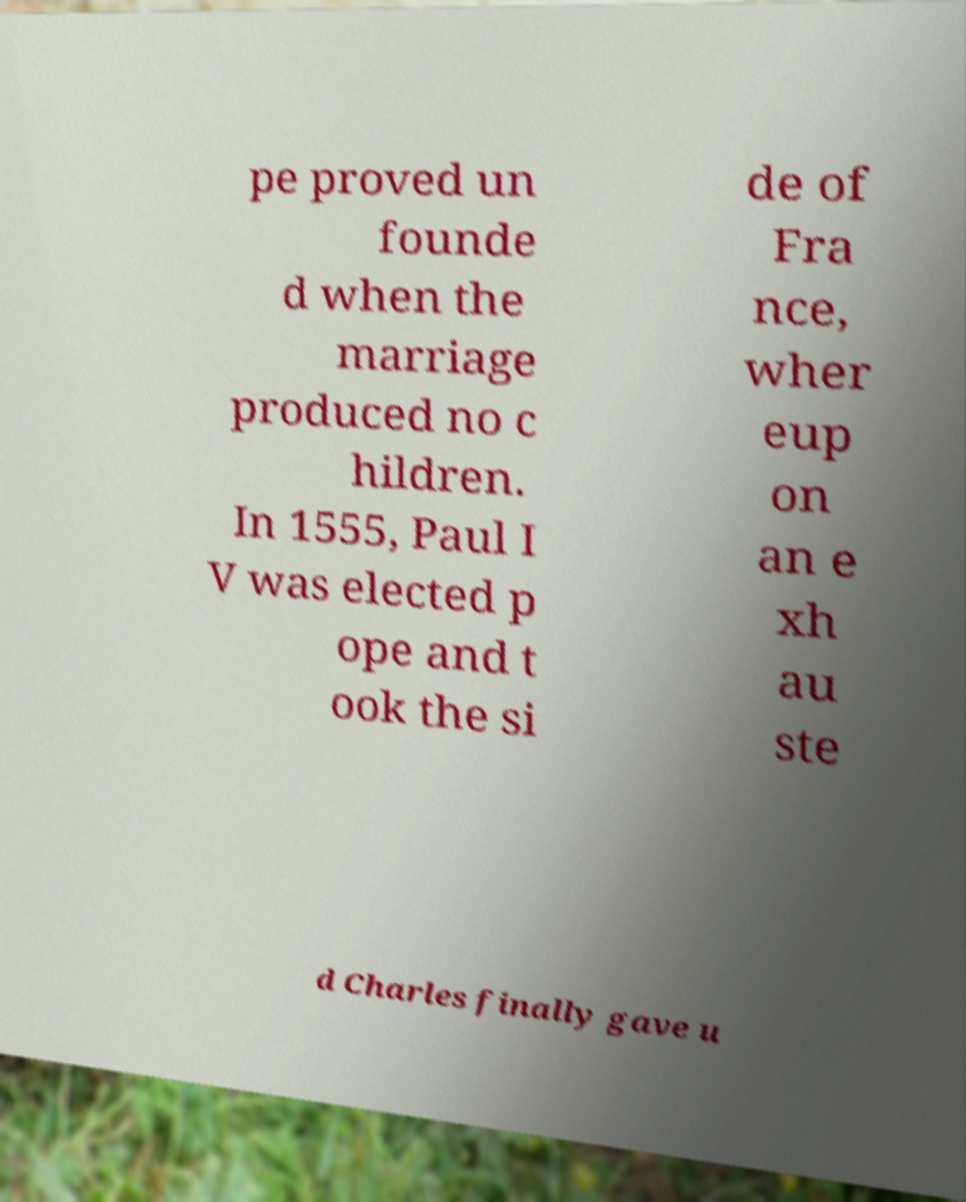For documentation purposes, I need the text within this image transcribed. Could you provide that? pe proved un founde d when the marriage produced no c hildren. In 1555, Paul I V was elected p ope and t ook the si de of Fra nce, wher eup on an e xh au ste d Charles finally gave u 